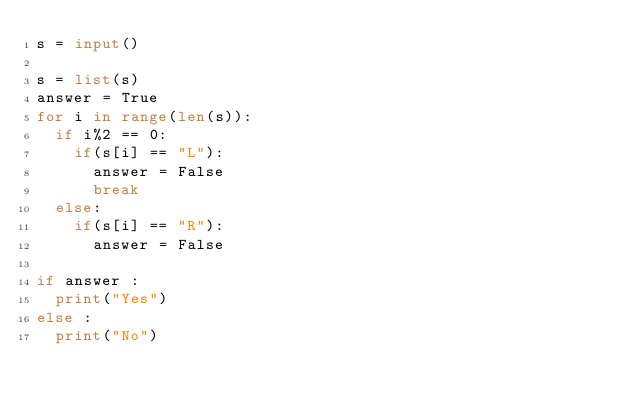Convert code to text. <code><loc_0><loc_0><loc_500><loc_500><_Python_>s = input()

s = list(s)
answer = True
for i in range(len(s)):
  if i%2 == 0:
    if(s[i] == "L"):
      answer = False
      break
  else:
    if(s[i] == "R"):
      answer = False

if answer :
  print("Yes")
else :
  print("No")</code> 